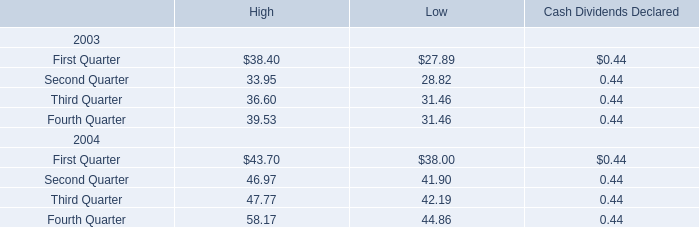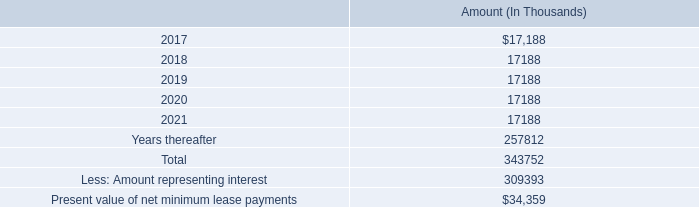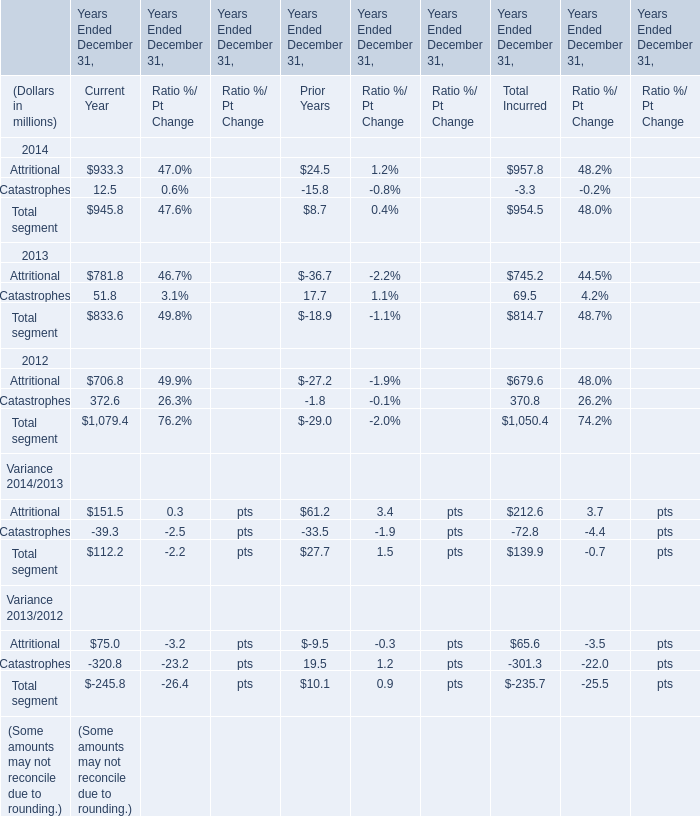What was the average of Attritional for Prior Years in 2014, 2013, and 2012 ? (in million) 
Computations: (((24.5 - 36.7) - 27.2) / 3)
Answer: -13.13333. 